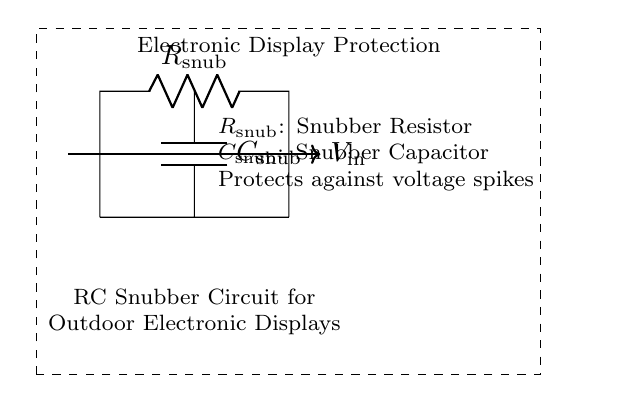What components are in the circuit? The circuit diagram contains a resistor labeled as snubber resistor and a capacitor labeled as snubber capacitor. These are the two main components used in an RC snubber circuit.
Answer: resistor, capacitor What does the snubber circuit protect against? The diagram specifies that the snubber circuit is designed to protect against voltage spikes, which are brief surge voltages that can damage electronic components.
Answer: voltage spikes What is the function of the resistor in this circuit? The resistor in the snubber circuit limits the current flow during transient voltage conditions, helping to dissipate excess energy. This is essential for protecting sensitive components like electronic displays.
Answer: current limiting What is the value labeled for the capacitor in the circuit? The circuit does not specify a numerical value for the capacitor; it only provides a label identifying it as a snubber capacitor without any further detail.
Answer: C snub What role does the capacitor play in this RC snubber circuit? The capacitor acts to absorb voltage spikes by charging and discharging quickly, which helps to smooth out rapid changes in voltage and protect the display from potential damage.
Answer: absorbs voltage spikes How would you describe the overall purpose of the RC snubber circuit shown? The overall purpose is to provide protection for outdoor electronic displays by mitigating the effects of voltage spikes and so ensuring reliable functionality in city environments.
Answer: protects displays 